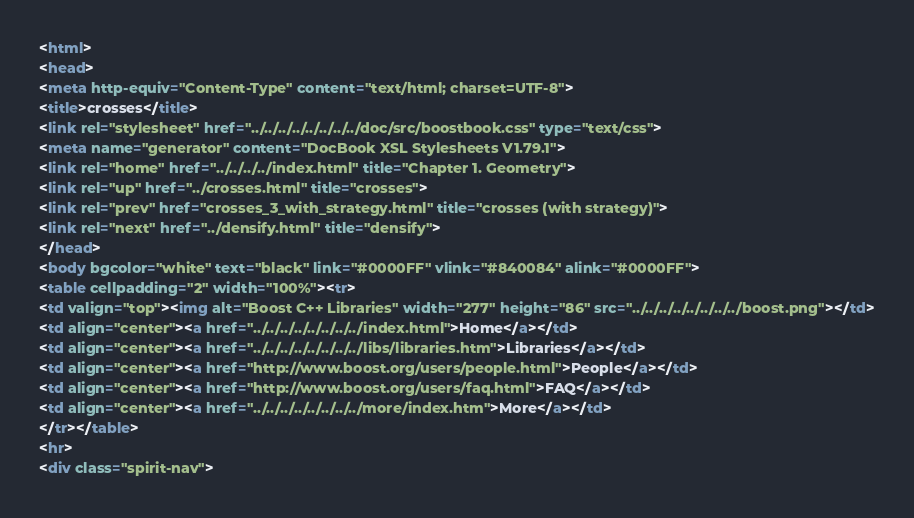Convert code to text. <code><loc_0><loc_0><loc_500><loc_500><_HTML_><html>
<head>
<meta http-equiv="Content-Type" content="text/html; charset=UTF-8">
<title>crosses</title>
<link rel="stylesheet" href="../../../../../../../../doc/src/boostbook.css" type="text/css">
<meta name="generator" content="DocBook XSL Stylesheets V1.79.1">
<link rel="home" href="../../../../index.html" title="Chapter 1. Geometry">
<link rel="up" href="../crosses.html" title="crosses">
<link rel="prev" href="crosses_3_with_strategy.html" title="crosses (with strategy)">
<link rel="next" href="../densify.html" title="densify">
</head>
<body bgcolor="white" text="black" link="#0000FF" vlink="#840084" alink="#0000FF">
<table cellpadding="2" width="100%"><tr>
<td valign="top"><img alt="Boost C++ Libraries" width="277" height="86" src="../../../../../../../../boost.png"></td>
<td align="center"><a href="../../../../../../../../index.html">Home</a></td>
<td align="center"><a href="../../../../../../../../libs/libraries.htm">Libraries</a></td>
<td align="center"><a href="http://www.boost.org/users/people.html">People</a></td>
<td align="center"><a href="http://www.boost.org/users/faq.html">FAQ</a></td>
<td align="center"><a href="../../../../../../../../more/index.htm">More</a></td>
</tr></table>
<hr>
<div class="spirit-nav"></code> 